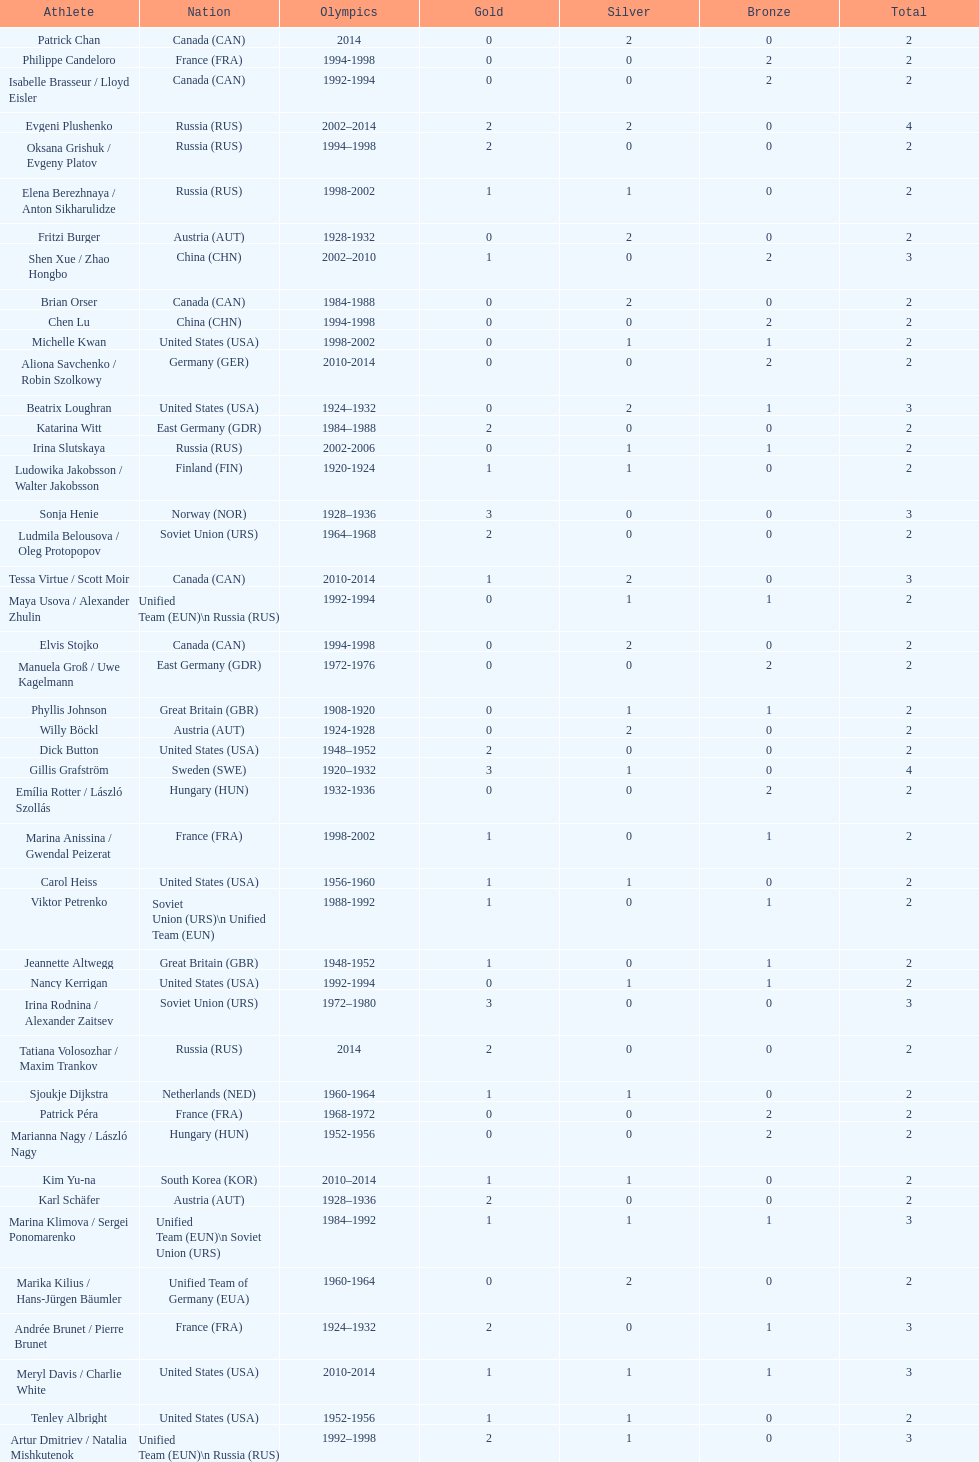How many medals have sweden and norway won combined? 7. 